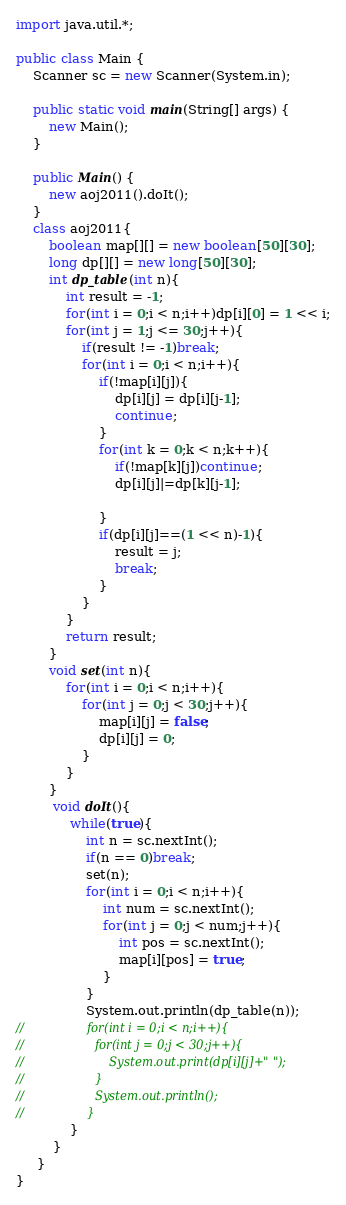Convert code to text. <code><loc_0><loc_0><loc_500><loc_500><_Java_>import java.util.*;
  
public class Main {
    Scanner sc = new Scanner(System.in);
  
    public static void main(String[] args) {
        new Main(); 
    }
  
    public Main() {
        new aoj2011().doIt();
    }
    class aoj2011{
    	boolean map[][] = new boolean[50][30];
    	long dp[][] = new long[50][30];
    	int dp_table(int n){
    		int result = -1;
    		for(int i = 0;i < n;i++)dp[i][0] = 1 << i;
            for(int j = 1;j <= 30;j++){
                if(result != -1)break;
                for(int i = 0;i < n;i++){
                    if(!map[i][j]){
                        dp[i][j] = dp[i][j-1]; 
                        continue;
                    }
                    for(int k = 0;k < n;k++){
                        if(!map[k][j])continue;
                        dp[i][j]|=dp[k][j-1];
                        
                    }
                    if(dp[i][j]==(1 << n)-1){
                        result = j;
                        break;
                    }
                }
            }
            return result;
    	}
    	void set(int n){
    		for(int i = 0;i < n;i++){
    			for(int j = 0;j < 30;j++){
    				map[i][j] = false;
    				dp[i][j] = 0;
    			}
    		}
    	}
         void doIt(){
        	 while(true){
        		 int n = sc.nextInt();
        		 if(n == 0)break;
        		 set(n);
        		 for(int i = 0;i < n;i++){
        			 int num = sc.nextInt();
        			 for(int j = 0;j < num;j++){
        				 int pos = sc.nextInt();
        				 map[i][pos] = true;
        			 }
        		 }
                 System.out.println(dp_table(n));
//                 for(int i = 0;i < n;i++){
//                	 for(int j = 0;j < 30;j++){
//                		 System.out.print(dp[i][j]+" ");
//                	 }
//                	 System.out.println();
//                 }
             }
         }
     }
}</code> 